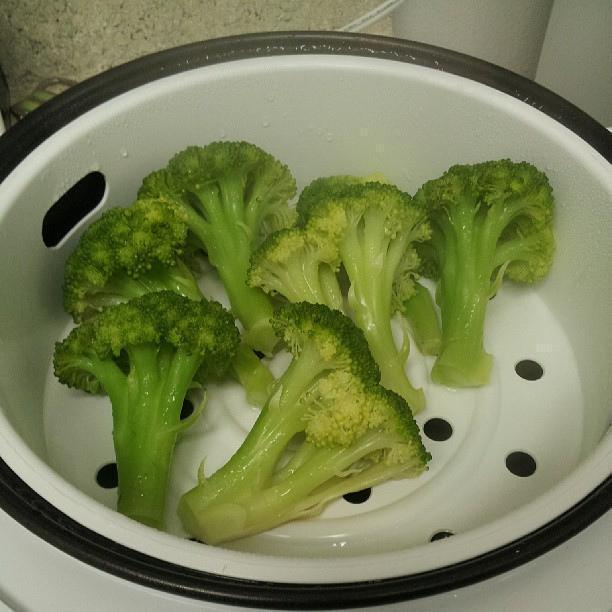What is the method being used to cook the broccoli?
Choose the right answer from the provided options to respond to the question.
Options: Bake, steam, fry, grill. Steam. 